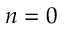Convert formula to latex. <formula><loc_0><loc_0><loc_500><loc_500>n = 0</formula> 